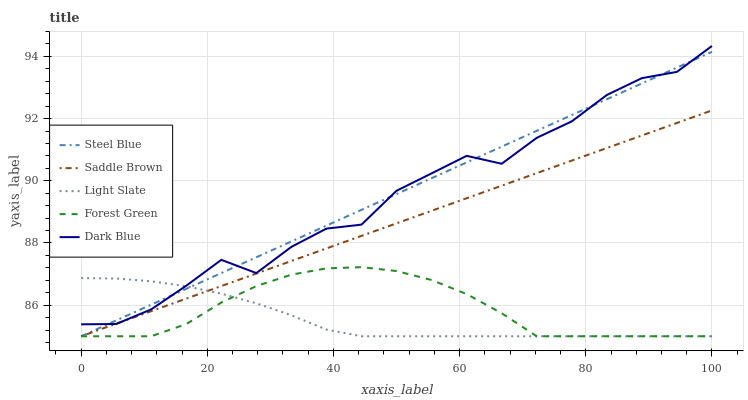Does Light Slate have the minimum area under the curve?
Answer yes or no. Yes. Does Steel Blue have the maximum area under the curve?
Answer yes or no. Yes. Does Dark Blue have the minimum area under the curve?
Answer yes or no. No. Does Dark Blue have the maximum area under the curve?
Answer yes or no. No. Is Saddle Brown the smoothest?
Answer yes or no. Yes. Is Dark Blue the roughest?
Answer yes or no. Yes. Is Forest Green the smoothest?
Answer yes or no. No. Is Forest Green the roughest?
Answer yes or no. No. Does Light Slate have the lowest value?
Answer yes or no. Yes. Does Dark Blue have the lowest value?
Answer yes or no. No. Does Dark Blue have the highest value?
Answer yes or no. Yes. Does Forest Green have the highest value?
Answer yes or no. No. Is Forest Green less than Dark Blue?
Answer yes or no. Yes. Is Dark Blue greater than Forest Green?
Answer yes or no. Yes. Does Forest Green intersect Light Slate?
Answer yes or no. Yes. Is Forest Green less than Light Slate?
Answer yes or no. No. Is Forest Green greater than Light Slate?
Answer yes or no. No. Does Forest Green intersect Dark Blue?
Answer yes or no. No. 